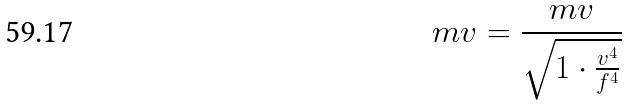Convert formula to latex. <formula><loc_0><loc_0><loc_500><loc_500>m v = \frac { m v } { \sqrt { 1 \cdot \frac { v ^ { 4 } } { f ^ { 4 } } } }</formula> 